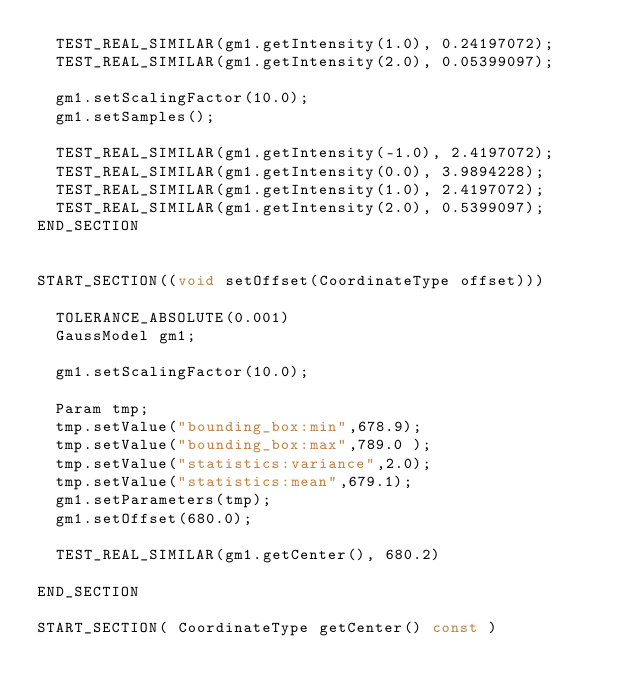<code> <loc_0><loc_0><loc_500><loc_500><_C++_>	TEST_REAL_SIMILAR(gm1.getIntensity(1.0), 0.24197072);
	TEST_REAL_SIMILAR(gm1.getIntensity(2.0), 0.05399097);

	gm1.setScalingFactor(10.0);
	gm1.setSamples();

	TEST_REAL_SIMILAR(gm1.getIntensity(-1.0), 2.4197072);
	TEST_REAL_SIMILAR(gm1.getIntensity(0.0), 3.9894228);
	TEST_REAL_SIMILAR(gm1.getIntensity(1.0), 2.4197072);
	TEST_REAL_SIMILAR(gm1.getIntensity(2.0), 0.5399097);
END_SECTION


START_SECTION((void setOffset(CoordinateType offset)))

	TOLERANCE_ABSOLUTE(0.001)
	GaussModel gm1;
	
	gm1.setScalingFactor(10.0);
	
	Param tmp;
	tmp.setValue("bounding_box:min",678.9);
	tmp.setValue("bounding_box:max",789.0 );
	tmp.setValue("statistics:variance",2.0);
	tmp.setValue("statistics:mean",679.1);			
	gm1.setParameters(tmp);
	gm1.setOffset(680.0);

	TEST_REAL_SIMILAR(gm1.getCenter(), 680.2)

END_SECTION

START_SECTION( CoordinateType getCenter() const )</code> 